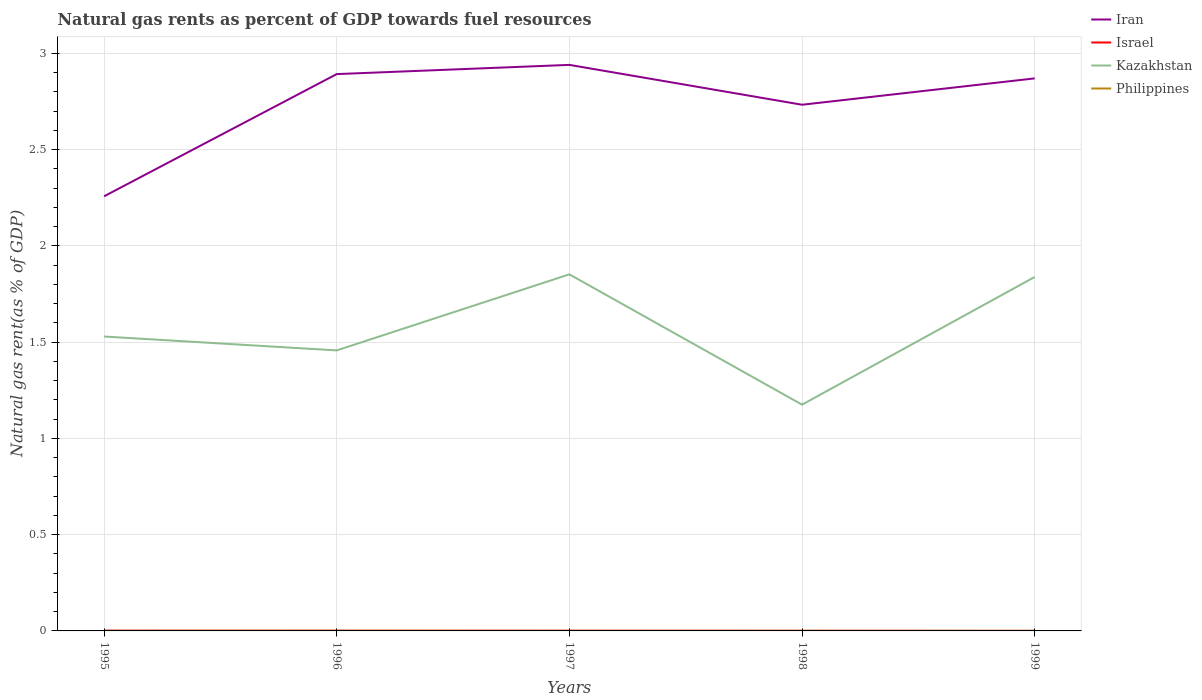How many different coloured lines are there?
Your response must be concise. 4. Does the line corresponding to Philippines intersect with the line corresponding to Kazakhstan?
Give a very brief answer. No. Across all years, what is the maximum natural gas rent in Philippines?
Give a very brief answer. 0. In which year was the natural gas rent in Israel maximum?
Provide a succinct answer. 1999. What is the total natural gas rent in Iran in the graph?
Give a very brief answer. 0.07. What is the difference between the highest and the second highest natural gas rent in Iran?
Offer a very short reply. 0.68. What is the difference between the highest and the lowest natural gas rent in Israel?
Ensure brevity in your answer.  3. Is the natural gas rent in Philippines strictly greater than the natural gas rent in Israel over the years?
Ensure brevity in your answer.  No. Does the graph contain any zero values?
Your response must be concise. No. Does the graph contain grids?
Provide a succinct answer. Yes. Where does the legend appear in the graph?
Offer a terse response. Top right. How many legend labels are there?
Your answer should be compact. 4. How are the legend labels stacked?
Keep it short and to the point. Vertical. What is the title of the graph?
Ensure brevity in your answer.  Natural gas rents as percent of GDP towards fuel resources. Does "Angola" appear as one of the legend labels in the graph?
Keep it short and to the point. No. What is the label or title of the Y-axis?
Offer a very short reply. Natural gas rent(as % of GDP). What is the Natural gas rent(as % of GDP) in Iran in 1995?
Give a very brief answer. 2.26. What is the Natural gas rent(as % of GDP) of Israel in 1995?
Provide a short and direct response. 0. What is the Natural gas rent(as % of GDP) in Kazakhstan in 1995?
Keep it short and to the point. 1.53. What is the Natural gas rent(as % of GDP) of Philippines in 1995?
Offer a very short reply. 0. What is the Natural gas rent(as % of GDP) of Iran in 1996?
Offer a terse response. 2.89. What is the Natural gas rent(as % of GDP) in Israel in 1996?
Ensure brevity in your answer.  0. What is the Natural gas rent(as % of GDP) of Kazakhstan in 1996?
Offer a terse response. 1.46. What is the Natural gas rent(as % of GDP) in Philippines in 1996?
Provide a succinct answer. 0. What is the Natural gas rent(as % of GDP) of Iran in 1997?
Make the answer very short. 2.94. What is the Natural gas rent(as % of GDP) in Israel in 1997?
Ensure brevity in your answer.  0. What is the Natural gas rent(as % of GDP) of Kazakhstan in 1997?
Your answer should be very brief. 1.85. What is the Natural gas rent(as % of GDP) of Philippines in 1997?
Keep it short and to the point. 0. What is the Natural gas rent(as % of GDP) of Iran in 1998?
Your response must be concise. 2.73. What is the Natural gas rent(as % of GDP) of Israel in 1998?
Offer a very short reply. 0. What is the Natural gas rent(as % of GDP) of Kazakhstan in 1998?
Make the answer very short. 1.18. What is the Natural gas rent(as % of GDP) of Philippines in 1998?
Your answer should be compact. 0. What is the Natural gas rent(as % of GDP) in Iran in 1999?
Make the answer very short. 2.87. What is the Natural gas rent(as % of GDP) in Israel in 1999?
Keep it short and to the point. 0. What is the Natural gas rent(as % of GDP) in Kazakhstan in 1999?
Ensure brevity in your answer.  1.84. What is the Natural gas rent(as % of GDP) in Philippines in 1999?
Make the answer very short. 0. Across all years, what is the maximum Natural gas rent(as % of GDP) of Iran?
Make the answer very short. 2.94. Across all years, what is the maximum Natural gas rent(as % of GDP) of Israel?
Offer a very short reply. 0. Across all years, what is the maximum Natural gas rent(as % of GDP) of Kazakhstan?
Your response must be concise. 1.85. Across all years, what is the maximum Natural gas rent(as % of GDP) of Philippines?
Your response must be concise. 0. Across all years, what is the minimum Natural gas rent(as % of GDP) of Iran?
Offer a very short reply. 2.26. Across all years, what is the minimum Natural gas rent(as % of GDP) of Israel?
Ensure brevity in your answer.  0. Across all years, what is the minimum Natural gas rent(as % of GDP) in Kazakhstan?
Keep it short and to the point. 1.18. Across all years, what is the minimum Natural gas rent(as % of GDP) in Philippines?
Provide a short and direct response. 0. What is the total Natural gas rent(as % of GDP) in Iran in the graph?
Offer a terse response. 13.69. What is the total Natural gas rent(as % of GDP) in Israel in the graph?
Keep it short and to the point. 0. What is the total Natural gas rent(as % of GDP) in Kazakhstan in the graph?
Your answer should be compact. 7.85. What is the total Natural gas rent(as % of GDP) in Philippines in the graph?
Make the answer very short. 0. What is the difference between the Natural gas rent(as % of GDP) of Iran in 1995 and that in 1996?
Keep it short and to the point. -0.63. What is the difference between the Natural gas rent(as % of GDP) in Kazakhstan in 1995 and that in 1996?
Provide a short and direct response. 0.07. What is the difference between the Natural gas rent(as % of GDP) of Philippines in 1995 and that in 1996?
Keep it short and to the point. -0. What is the difference between the Natural gas rent(as % of GDP) of Iran in 1995 and that in 1997?
Provide a succinct answer. -0.68. What is the difference between the Natural gas rent(as % of GDP) in Israel in 1995 and that in 1997?
Make the answer very short. 0. What is the difference between the Natural gas rent(as % of GDP) in Kazakhstan in 1995 and that in 1997?
Your response must be concise. -0.32. What is the difference between the Natural gas rent(as % of GDP) of Philippines in 1995 and that in 1997?
Your response must be concise. -0. What is the difference between the Natural gas rent(as % of GDP) of Iran in 1995 and that in 1998?
Your response must be concise. -0.48. What is the difference between the Natural gas rent(as % of GDP) in Israel in 1995 and that in 1998?
Give a very brief answer. 0. What is the difference between the Natural gas rent(as % of GDP) in Kazakhstan in 1995 and that in 1998?
Keep it short and to the point. 0.35. What is the difference between the Natural gas rent(as % of GDP) of Philippines in 1995 and that in 1998?
Keep it short and to the point. -0. What is the difference between the Natural gas rent(as % of GDP) in Iran in 1995 and that in 1999?
Make the answer very short. -0.61. What is the difference between the Natural gas rent(as % of GDP) in Kazakhstan in 1995 and that in 1999?
Offer a very short reply. -0.31. What is the difference between the Natural gas rent(as % of GDP) in Philippines in 1995 and that in 1999?
Your response must be concise. -0. What is the difference between the Natural gas rent(as % of GDP) in Iran in 1996 and that in 1997?
Your answer should be very brief. -0.05. What is the difference between the Natural gas rent(as % of GDP) of Kazakhstan in 1996 and that in 1997?
Make the answer very short. -0.4. What is the difference between the Natural gas rent(as % of GDP) of Iran in 1996 and that in 1998?
Give a very brief answer. 0.16. What is the difference between the Natural gas rent(as % of GDP) of Israel in 1996 and that in 1998?
Offer a very short reply. 0. What is the difference between the Natural gas rent(as % of GDP) of Kazakhstan in 1996 and that in 1998?
Your response must be concise. 0.28. What is the difference between the Natural gas rent(as % of GDP) of Iran in 1996 and that in 1999?
Your response must be concise. 0.02. What is the difference between the Natural gas rent(as % of GDP) of Israel in 1996 and that in 1999?
Your response must be concise. 0. What is the difference between the Natural gas rent(as % of GDP) of Kazakhstan in 1996 and that in 1999?
Your answer should be compact. -0.38. What is the difference between the Natural gas rent(as % of GDP) in Philippines in 1996 and that in 1999?
Give a very brief answer. 0. What is the difference between the Natural gas rent(as % of GDP) of Iran in 1997 and that in 1998?
Your answer should be very brief. 0.21. What is the difference between the Natural gas rent(as % of GDP) in Kazakhstan in 1997 and that in 1998?
Your answer should be compact. 0.68. What is the difference between the Natural gas rent(as % of GDP) of Philippines in 1997 and that in 1998?
Ensure brevity in your answer.  -0. What is the difference between the Natural gas rent(as % of GDP) of Iran in 1997 and that in 1999?
Give a very brief answer. 0.07. What is the difference between the Natural gas rent(as % of GDP) of Israel in 1997 and that in 1999?
Make the answer very short. 0. What is the difference between the Natural gas rent(as % of GDP) of Kazakhstan in 1997 and that in 1999?
Offer a very short reply. 0.01. What is the difference between the Natural gas rent(as % of GDP) of Iran in 1998 and that in 1999?
Your answer should be very brief. -0.14. What is the difference between the Natural gas rent(as % of GDP) in Kazakhstan in 1998 and that in 1999?
Offer a very short reply. -0.66. What is the difference between the Natural gas rent(as % of GDP) of Iran in 1995 and the Natural gas rent(as % of GDP) of Israel in 1996?
Offer a terse response. 2.26. What is the difference between the Natural gas rent(as % of GDP) of Iran in 1995 and the Natural gas rent(as % of GDP) of Kazakhstan in 1996?
Provide a short and direct response. 0.8. What is the difference between the Natural gas rent(as % of GDP) of Iran in 1995 and the Natural gas rent(as % of GDP) of Philippines in 1996?
Your answer should be compact. 2.26. What is the difference between the Natural gas rent(as % of GDP) in Israel in 1995 and the Natural gas rent(as % of GDP) in Kazakhstan in 1996?
Offer a very short reply. -1.46. What is the difference between the Natural gas rent(as % of GDP) in Kazakhstan in 1995 and the Natural gas rent(as % of GDP) in Philippines in 1996?
Provide a short and direct response. 1.53. What is the difference between the Natural gas rent(as % of GDP) of Iran in 1995 and the Natural gas rent(as % of GDP) of Israel in 1997?
Give a very brief answer. 2.26. What is the difference between the Natural gas rent(as % of GDP) in Iran in 1995 and the Natural gas rent(as % of GDP) in Kazakhstan in 1997?
Offer a very short reply. 0.41. What is the difference between the Natural gas rent(as % of GDP) in Iran in 1995 and the Natural gas rent(as % of GDP) in Philippines in 1997?
Your answer should be very brief. 2.26. What is the difference between the Natural gas rent(as % of GDP) in Israel in 1995 and the Natural gas rent(as % of GDP) in Kazakhstan in 1997?
Your answer should be very brief. -1.85. What is the difference between the Natural gas rent(as % of GDP) in Israel in 1995 and the Natural gas rent(as % of GDP) in Philippines in 1997?
Your response must be concise. 0. What is the difference between the Natural gas rent(as % of GDP) of Kazakhstan in 1995 and the Natural gas rent(as % of GDP) of Philippines in 1997?
Provide a succinct answer. 1.53. What is the difference between the Natural gas rent(as % of GDP) in Iran in 1995 and the Natural gas rent(as % of GDP) in Israel in 1998?
Make the answer very short. 2.26. What is the difference between the Natural gas rent(as % of GDP) in Iran in 1995 and the Natural gas rent(as % of GDP) in Kazakhstan in 1998?
Offer a terse response. 1.08. What is the difference between the Natural gas rent(as % of GDP) in Iran in 1995 and the Natural gas rent(as % of GDP) in Philippines in 1998?
Provide a succinct answer. 2.26. What is the difference between the Natural gas rent(as % of GDP) in Israel in 1995 and the Natural gas rent(as % of GDP) in Kazakhstan in 1998?
Offer a very short reply. -1.17. What is the difference between the Natural gas rent(as % of GDP) in Israel in 1995 and the Natural gas rent(as % of GDP) in Philippines in 1998?
Make the answer very short. 0. What is the difference between the Natural gas rent(as % of GDP) of Kazakhstan in 1995 and the Natural gas rent(as % of GDP) of Philippines in 1998?
Make the answer very short. 1.53. What is the difference between the Natural gas rent(as % of GDP) of Iran in 1995 and the Natural gas rent(as % of GDP) of Israel in 1999?
Offer a terse response. 2.26. What is the difference between the Natural gas rent(as % of GDP) in Iran in 1995 and the Natural gas rent(as % of GDP) in Kazakhstan in 1999?
Your answer should be very brief. 0.42. What is the difference between the Natural gas rent(as % of GDP) of Iran in 1995 and the Natural gas rent(as % of GDP) of Philippines in 1999?
Provide a short and direct response. 2.26. What is the difference between the Natural gas rent(as % of GDP) in Israel in 1995 and the Natural gas rent(as % of GDP) in Kazakhstan in 1999?
Keep it short and to the point. -1.84. What is the difference between the Natural gas rent(as % of GDP) of Israel in 1995 and the Natural gas rent(as % of GDP) of Philippines in 1999?
Give a very brief answer. 0. What is the difference between the Natural gas rent(as % of GDP) of Kazakhstan in 1995 and the Natural gas rent(as % of GDP) of Philippines in 1999?
Your answer should be very brief. 1.53. What is the difference between the Natural gas rent(as % of GDP) in Iran in 1996 and the Natural gas rent(as % of GDP) in Israel in 1997?
Keep it short and to the point. 2.89. What is the difference between the Natural gas rent(as % of GDP) in Iran in 1996 and the Natural gas rent(as % of GDP) in Kazakhstan in 1997?
Keep it short and to the point. 1.04. What is the difference between the Natural gas rent(as % of GDP) of Iran in 1996 and the Natural gas rent(as % of GDP) of Philippines in 1997?
Make the answer very short. 2.89. What is the difference between the Natural gas rent(as % of GDP) in Israel in 1996 and the Natural gas rent(as % of GDP) in Kazakhstan in 1997?
Provide a short and direct response. -1.85. What is the difference between the Natural gas rent(as % of GDP) of Israel in 1996 and the Natural gas rent(as % of GDP) of Philippines in 1997?
Your answer should be compact. 0. What is the difference between the Natural gas rent(as % of GDP) of Kazakhstan in 1996 and the Natural gas rent(as % of GDP) of Philippines in 1997?
Offer a terse response. 1.46. What is the difference between the Natural gas rent(as % of GDP) in Iran in 1996 and the Natural gas rent(as % of GDP) in Israel in 1998?
Offer a very short reply. 2.89. What is the difference between the Natural gas rent(as % of GDP) in Iran in 1996 and the Natural gas rent(as % of GDP) in Kazakhstan in 1998?
Your answer should be compact. 1.72. What is the difference between the Natural gas rent(as % of GDP) of Iran in 1996 and the Natural gas rent(as % of GDP) of Philippines in 1998?
Your response must be concise. 2.89. What is the difference between the Natural gas rent(as % of GDP) of Israel in 1996 and the Natural gas rent(as % of GDP) of Kazakhstan in 1998?
Ensure brevity in your answer.  -1.17. What is the difference between the Natural gas rent(as % of GDP) of Kazakhstan in 1996 and the Natural gas rent(as % of GDP) of Philippines in 1998?
Your response must be concise. 1.46. What is the difference between the Natural gas rent(as % of GDP) of Iran in 1996 and the Natural gas rent(as % of GDP) of Israel in 1999?
Offer a very short reply. 2.89. What is the difference between the Natural gas rent(as % of GDP) in Iran in 1996 and the Natural gas rent(as % of GDP) in Kazakhstan in 1999?
Make the answer very short. 1.05. What is the difference between the Natural gas rent(as % of GDP) of Iran in 1996 and the Natural gas rent(as % of GDP) of Philippines in 1999?
Give a very brief answer. 2.89. What is the difference between the Natural gas rent(as % of GDP) in Israel in 1996 and the Natural gas rent(as % of GDP) in Kazakhstan in 1999?
Provide a short and direct response. -1.84. What is the difference between the Natural gas rent(as % of GDP) of Israel in 1996 and the Natural gas rent(as % of GDP) of Philippines in 1999?
Give a very brief answer. 0. What is the difference between the Natural gas rent(as % of GDP) of Kazakhstan in 1996 and the Natural gas rent(as % of GDP) of Philippines in 1999?
Your answer should be compact. 1.46. What is the difference between the Natural gas rent(as % of GDP) of Iran in 1997 and the Natural gas rent(as % of GDP) of Israel in 1998?
Provide a short and direct response. 2.94. What is the difference between the Natural gas rent(as % of GDP) of Iran in 1997 and the Natural gas rent(as % of GDP) of Kazakhstan in 1998?
Ensure brevity in your answer.  1.76. What is the difference between the Natural gas rent(as % of GDP) in Iran in 1997 and the Natural gas rent(as % of GDP) in Philippines in 1998?
Provide a short and direct response. 2.94. What is the difference between the Natural gas rent(as % of GDP) of Israel in 1997 and the Natural gas rent(as % of GDP) of Kazakhstan in 1998?
Provide a short and direct response. -1.17. What is the difference between the Natural gas rent(as % of GDP) of Israel in 1997 and the Natural gas rent(as % of GDP) of Philippines in 1998?
Make the answer very short. 0. What is the difference between the Natural gas rent(as % of GDP) of Kazakhstan in 1997 and the Natural gas rent(as % of GDP) of Philippines in 1998?
Give a very brief answer. 1.85. What is the difference between the Natural gas rent(as % of GDP) of Iran in 1997 and the Natural gas rent(as % of GDP) of Israel in 1999?
Ensure brevity in your answer.  2.94. What is the difference between the Natural gas rent(as % of GDP) of Iran in 1997 and the Natural gas rent(as % of GDP) of Kazakhstan in 1999?
Give a very brief answer. 1.1. What is the difference between the Natural gas rent(as % of GDP) of Iran in 1997 and the Natural gas rent(as % of GDP) of Philippines in 1999?
Keep it short and to the point. 2.94. What is the difference between the Natural gas rent(as % of GDP) of Israel in 1997 and the Natural gas rent(as % of GDP) of Kazakhstan in 1999?
Your answer should be very brief. -1.84. What is the difference between the Natural gas rent(as % of GDP) of Israel in 1997 and the Natural gas rent(as % of GDP) of Philippines in 1999?
Your response must be concise. 0. What is the difference between the Natural gas rent(as % of GDP) of Kazakhstan in 1997 and the Natural gas rent(as % of GDP) of Philippines in 1999?
Provide a succinct answer. 1.85. What is the difference between the Natural gas rent(as % of GDP) in Iran in 1998 and the Natural gas rent(as % of GDP) in Israel in 1999?
Offer a very short reply. 2.73. What is the difference between the Natural gas rent(as % of GDP) in Iran in 1998 and the Natural gas rent(as % of GDP) in Kazakhstan in 1999?
Offer a terse response. 0.89. What is the difference between the Natural gas rent(as % of GDP) in Iran in 1998 and the Natural gas rent(as % of GDP) in Philippines in 1999?
Provide a short and direct response. 2.73. What is the difference between the Natural gas rent(as % of GDP) of Israel in 1998 and the Natural gas rent(as % of GDP) of Kazakhstan in 1999?
Ensure brevity in your answer.  -1.84. What is the difference between the Natural gas rent(as % of GDP) in Israel in 1998 and the Natural gas rent(as % of GDP) in Philippines in 1999?
Your answer should be very brief. 0. What is the difference between the Natural gas rent(as % of GDP) of Kazakhstan in 1998 and the Natural gas rent(as % of GDP) of Philippines in 1999?
Your answer should be very brief. 1.17. What is the average Natural gas rent(as % of GDP) in Iran per year?
Offer a very short reply. 2.74. What is the average Natural gas rent(as % of GDP) in Israel per year?
Offer a very short reply. 0. What is the average Natural gas rent(as % of GDP) in Kazakhstan per year?
Provide a short and direct response. 1.57. What is the average Natural gas rent(as % of GDP) of Philippines per year?
Offer a terse response. 0. In the year 1995, what is the difference between the Natural gas rent(as % of GDP) in Iran and Natural gas rent(as % of GDP) in Israel?
Provide a short and direct response. 2.26. In the year 1995, what is the difference between the Natural gas rent(as % of GDP) in Iran and Natural gas rent(as % of GDP) in Kazakhstan?
Ensure brevity in your answer.  0.73. In the year 1995, what is the difference between the Natural gas rent(as % of GDP) of Iran and Natural gas rent(as % of GDP) of Philippines?
Offer a very short reply. 2.26. In the year 1995, what is the difference between the Natural gas rent(as % of GDP) in Israel and Natural gas rent(as % of GDP) in Kazakhstan?
Provide a short and direct response. -1.53. In the year 1995, what is the difference between the Natural gas rent(as % of GDP) of Kazakhstan and Natural gas rent(as % of GDP) of Philippines?
Your answer should be very brief. 1.53. In the year 1996, what is the difference between the Natural gas rent(as % of GDP) of Iran and Natural gas rent(as % of GDP) of Israel?
Provide a succinct answer. 2.89. In the year 1996, what is the difference between the Natural gas rent(as % of GDP) of Iran and Natural gas rent(as % of GDP) of Kazakhstan?
Your response must be concise. 1.44. In the year 1996, what is the difference between the Natural gas rent(as % of GDP) in Iran and Natural gas rent(as % of GDP) in Philippines?
Provide a short and direct response. 2.89. In the year 1996, what is the difference between the Natural gas rent(as % of GDP) of Israel and Natural gas rent(as % of GDP) of Kazakhstan?
Your response must be concise. -1.46. In the year 1996, what is the difference between the Natural gas rent(as % of GDP) of Israel and Natural gas rent(as % of GDP) of Philippines?
Offer a very short reply. 0. In the year 1996, what is the difference between the Natural gas rent(as % of GDP) of Kazakhstan and Natural gas rent(as % of GDP) of Philippines?
Provide a succinct answer. 1.46. In the year 1997, what is the difference between the Natural gas rent(as % of GDP) in Iran and Natural gas rent(as % of GDP) in Israel?
Ensure brevity in your answer.  2.94. In the year 1997, what is the difference between the Natural gas rent(as % of GDP) of Iran and Natural gas rent(as % of GDP) of Kazakhstan?
Provide a succinct answer. 1.09. In the year 1997, what is the difference between the Natural gas rent(as % of GDP) in Iran and Natural gas rent(as % of GDP) in Philippines?
Your answer should be compact. 2.94. In the year 1997, what is the difference between the Natural gas rent(as % of GDP) of Israel and Natural gas rent(as % of GDP) of Kazakhstan?
Offer a very short reply. -1.85. In the year 1997, what is the difference between the Natural gas rent(as % of GDP) in Israel and Natural gas rent(as % of GDP) in Philippines?
Your response must be concise. 0. In the year 1997, what is the difference between the Natural gas rent(as % of GDP) of Kazakhstan and Natural gas rent(as % of GDP) of Philippines?
Make the answer very short. 1.85. In the year 1998, what is the difference between the Natural gas rent(as % of GDP) of Iran and Natural gas rent(as % of GDP) of Israel?
Make the answer very short. 2.73. In the year 1998, what is the difference between the Natural gas rent(as % of GDP) of Iran and Natural gas rent(as % of GDP) of Kazakhstan?
Your answer should be compact. 1.56. In the year 1998, what is the difference between the Natural gas rent(as % of GDP) in Iran and Natural gas rent(as % of GDP) in Philippines?
Your answer should be very brief. 2.73. In the year 1998, what is the difference between the Natural gas rent(as % of GDP) of Israel and Natural gas rent(as % of GDP) of Kazakhstan?
Provide a succinct answer. -1.17. In the year 1998, what is the difference between the Natural gas rent(as % of GDP) in Israel and Natural gas rent(as % of GDP) in Philippines?
Give a very brief answer. -0. In the year 1998, what is the difference between the Natural gas rent(as % of GDP) in Kazakhstan and Natural gas rent(as % of GDP) in Philippines?
Keep it short and to the point. 1.17. In the year 1999, what is the difference between the Natural gas rent(as % of GDP) in Iran and Natural gas rent(as % of GDP) in Israel?
Keep it short and to the point. 2.87. In the year 1999, what is the difference between the Natural gas rent(as % of GDP) in Iran and Natural gas rent(as % of GDP) in Kazakhstan?
Your response must be concise. 1.03. In the year 1999, what is the difference between the Natural gas rent(as % of GDP) in Iran and Natural gas rent(as % of GDP) in Philippines?
Make the answer very short. 2.87. In the year 1999, what is the difference between the Natural gas rent(as % of GDP) of Israel and Natural gas rent(as % of GDP) of Kazakhstan?
Give a very brief answer. -1.84. In the year 1999, what is the difference between the Natural gas rent(as % of GDP) in Israel and Natural gas rent(as % of GDP) in Philippines?
Offer a terse response. -0. In the year 1999, what is the difference between the Natural gas rent(as % of GDP) of Kazakhstan and Natural gas rent(as % of GDP) of Philippines?
Provide a succinct answer. 1.84. What is the ratio of the Natural gas rent(as % of GDP) in Iran in 1995 to that in 1996?
Give a very brief answer. 0.78. What is the ratio of the Natural gas rent(as % of GDP) in Israel in 1995 to that in 1996?
Provide a succinct answer. 1.29. What is the ratio of the Natural gas rent(as % of GDP) of Kazakhstan in 1995 to that in 1996?
Your answer should be compact. 1.05. What is the ratio of the Natural gas rent(as % of GDP) of Philippines in 1995 to that in 1996?
Ensure brevity in your answer.  0.5. What is the ratio of the Natural gas rent(as % of GDP) of Iran in 1995 to that in 1997?
Your answer should be compact. 0.77. What is the ratio of the Natural gas rent(as % of GDP) of Israel in 1995 to that in 1997?
Give a very brief answer. 1.38. What is the ratio of the Natural gas rent(as % of GDP) of Kazakhstan in 1995 to that in 1997?
Provide a short and direct response. 0.83. What is the ratio of the Natural gas rent(as % of GDP) in Philippines in 1995 to that in 1997?
Keep it short and to the point. 0.88. What is the ratio of the Natural gas rent(as % of GDP) in Iran in 1995 to that in 1998?
Ensure brevity in your answer.  0.83. What is the ratio of the Natural gas rent(as % of GDP) in Israel in 1995 to that in 1998?
Your response must be concise. 2.49. What is the ratio of the Natural gas rent(as % of GDP) in Kazakhstan in 1995 to that in 1998?
Your answer should be compact. 1.3. What is the ratio of the Natural gas rent(as % of GDP) of Philippines in 1995 to that in 1998?
Provide a short and direct response. 0.57. What is the ratio of the Natural gas rent(as % of GDP) in Iran in 1995 to that in 1999?
Make the answer very short. 0.79. What is the ratio of the Natural gas rent(as % of GDP) of Israel in 1995 to that in 1999?
Make the answer very short. 3.24. What is the ratio of the Natural gas rent(as % of GDP) of Kazakhstan in 1995 to that in 1999?
Make the answer very short. 0.83. What is the ratio of the Natural gas rent(as % of GDP) of Philippines in 1995 to that in 1999?
Give a very brief answer. 0.96. What is the ratio of the Natural gas rent(as % of GDP) in Iran in 1996 to that in 1997?
Keep it short and to the point. 0.98. What is the ratio of the Natural gas rent(as % of GDP) of Israel in 1996 to that in 1997?
Offer a terse response. 1.07. What is the ratio of the Natural gas rent(as % of GDP) of Kazakhstan in 1996 to that in 1997?
Offer a terse response. 0.79. What is the ratio of the Natural gas rent(as % of GDP) of Philippines in 1996 to that in 1997?
Ensure brevity in your answer.  1.77. What is the ratio of the Natural gas rent(as % of GDP) in Iran in 1996 to that in 1998?
Provide a succinct answer. 1.06. What is the ratio of the Natural gas rent(as % of GDP) of Israel in 1996 to that in 1998?
Offer a very short reply. 1.93. What is the ratio of the Natural gas rent(as % of GDP) in Kazakhstan in 1996 to that in 1998?
Offer a terse response. 1.24. What is the ratio of the Natural gas rent(as % of GDP) of Philippines in 1996 to that in 1998?
Your response must be concise. 1.15. What is the ratio of the Natural gas rent(as % of GDP) in Israel in 1996 to that in 1999?
Keep it short and to the point. 2.51. What is the ratio of the Natural gas rent(as % of GDP) in Kazakhstan in 1996 to that in 1999?
Your answer should be compact. 0.79. What is the ratio of the Natural gas rent(as % of GDP) of Philippines in 1996 to that in 1999?
Keep it short and to the point. 1.94. What is the ratio of the Natural gas rent(as % of GDP) in Iran in 1997 to that in 1998?
Your answer should be very brief. 1.08. What is the ratio of the Natural gas rent(as % of GDP) in Israel in 1997 to that in 1998?
Make the answer very short. 1.8. What is the ratio of the Natural gas rent(as % of GDP) in Kazakhstan in 1997 to that in 1998?
Make the answer very short. 1.58. What is the ratio of the Natural gas rent(as % of GDP) of Philippines in 1997 to that in 1998?
Your response must be concise. 0.65. What is the ratio of the Natural gas rent(as % of GDP) of Iran in 1997 to that in 1999?
Provide a succinct answer. 1.02. What is the ratio of the Natural gas rent(as % of GDP) of Israel in 1997 to that in 1999?
Give a very brief answer. 2.35. What is the ratio of the Natural gas rent(as % of GDP) of Kazakhstan in 1997 to that in 1999?
Keep it short and to the point. 1.01. What is the ratio of the Natural gas rent(as % of GDP) of Philippines in 1997 to that in 1999?
Your answer should be compact. 1.1. What is the ratio of the Natural gas rent(as % of GDP) in Iran in 1998 to that in 1999?
Your answer should be very brief. 0.95. What is the ratio of the Natural gas rent(as % of GDP) in Israel in 1998 to that in 1999?
Provide a succinct answer. 1.3. What is the ratio of the Natural gas rent(as % of GDP) in Kazakhstan in 1998 to that in 1999?
Offer a terse response. 0.64. What is the ratio of the Natural gas rent(as % of GDP) in Philippines in 1998 to that in 1999?
Your answer should be very brief. 1.69. What is the difference between the highest and the second highest Natural gas rent(as % of GDP) of Iran?
Ensure brevity in your answer.  0.05. What is the difference between the highest and the second highest Natural gas rent(as % of GDP) of Kazakhstan?
Give a very brief answer. 0.01. What is the difference between the highest and the second highest Natural gas rent(as % of GDP) of Philippines?
Offer a terse response. 0. What is the difference between the highest and the lowest Natural gas rent(as % of GDP) in Iran?
Provide a short and direct response. 0.68. What is the difference between the highest and the lowest Natural gas rent(as % of GDP) of Israel?
Your answer should be very brief. 0. What is the difference between the highest and the lowest Natural gas rent(as % of GDP) of Kazakhstan?
Provide a succinct answer. 0.68. What is the difference between the highest and the lowest Natural gas rent(as % of GDP) of Philippines?
Ensure brevity in your answer.  0. 